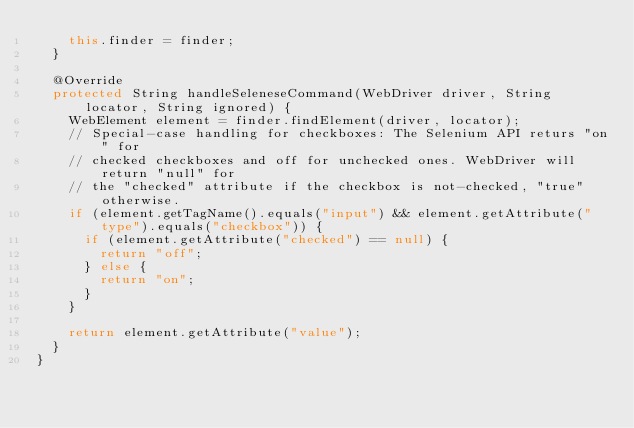<code> <loc_0><loc_0><loc_500><loc_500><_Java_>    this.finder = finder;
  }

  @Override
  protected String handleSeleneseCommand(WebDriver driver, String locator, String ignored) {
    WebElement element = finder.findElement(driver, locator);
    // Special-case handling for checkboxes: The Selenium API returs "on" for
    // checked checkboxes and off for unchecked ones. WebDriver will return "null" for
    // the "checked" attribute if the checkbox is not-checked, "true" otherwise.
    if (element.getTagName().equals("input") && element.getAttribute("type").equals("checkbox")) {
      if (element.getAttribute("checked") == null) {
        return "off";
      } else {
        return "on";
      }      
    }

    return element.getAttribute("value");
  }
}</code> 